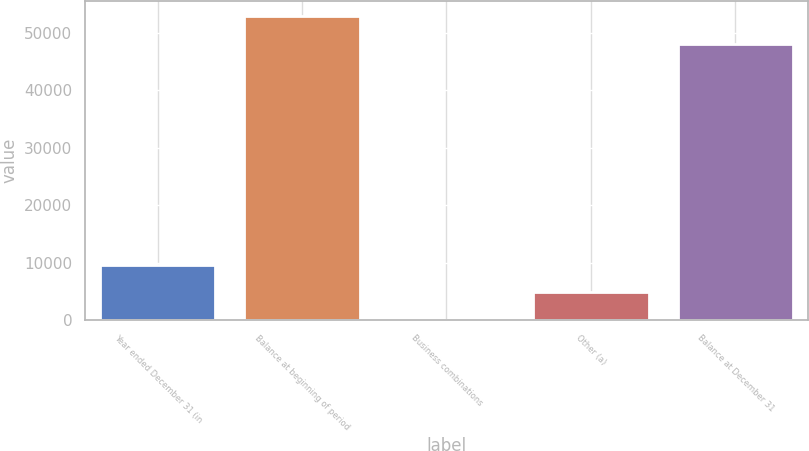<chart> <loc_0><loc_0><loc_500><loc_500><bar_chart><fcel>Year ended December 31 (in<fcel>Balance at beginning of period<fcel>Business combinations<fcel>Other (a)<fcel>Balance at December 31<nl><fcel>9686.2<fcel>52892.1<fcel>64<fcel>4875.1<fcel>48081<nl></chart> 